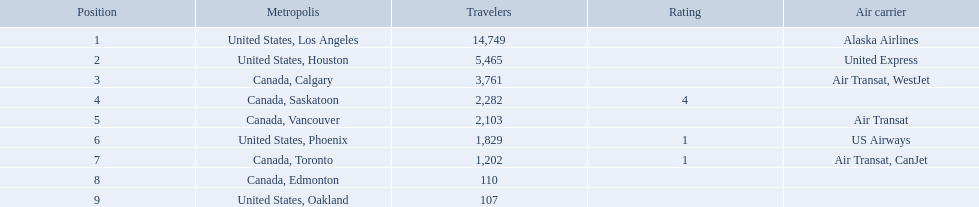Which airport has the least amount of passengers? 107. What airport has 107 passengers? United States, Oakland. Which cities had less than 2,000 passengers? United States, Phoenix, Canada, Toronto, Canada, Edmonton, United States, Oakland. Of these cities, which had fewer than 1,000 passengers? Canada, Edmonton, United States, Oakland. Of the cities in the previous answer, which one had only 107 passengers? United States, Oakland. 